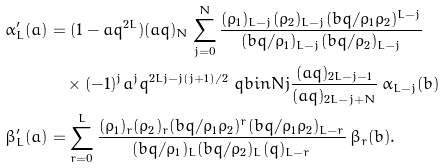Convert formula to latex. <formula><loc_0><loc_0><loc_500><loc_500>\alpha ^ { \prime } _ { L } ( a ) & = ( 1 - a q ^ { 2 L } ) ( a q ) _ { N } \sum _ { j = 0 } ^ { N } \frac { ( \rho _ { 1 } ) _ { L - j } ( \rho _ { 2 } ) _ { L - j } ( b q / \rho _ { 1 } \rho _ { 2 } ) ^ { L - j } } { ( b q / \rho _ { 1 } ) _ { L - j } ( b q / \rho _ { 2 } ) _ { L - j } } \\ & \quad \times ( - 1 ) ^ { j } a ^ { j } q ^ { 2 L j - j ( j + 1 ) / 2 } \ q b i n { N } { j } \frac { ( a q ) _ { 2 L - j - 1 } } { ( a q ) _ { 2 L - j + N } } \, \alpha _ { L - j } ( b ) \\ \beta ^ { \prime } _ { L } ( a ) & = \sum _ { r = 0 } ^ { L } \frac { ( \rho _ { 1 } ) _ { r } ( \rho _ { 2 } ) _ { r } ( b q / \rho _ { 1 } \rho _ { 2 } ) ^ { r } ( b q / \rho _ { 1 } \rho _ { 2 } ) _ { L - r } } { ( b q / \rho _ { 1 } ) _ { L } ( b q / \rho _ { 2 } ) _ { L } ( q ) _ { L - r } } \, \beta _ { r } ( b ) .</formula> 